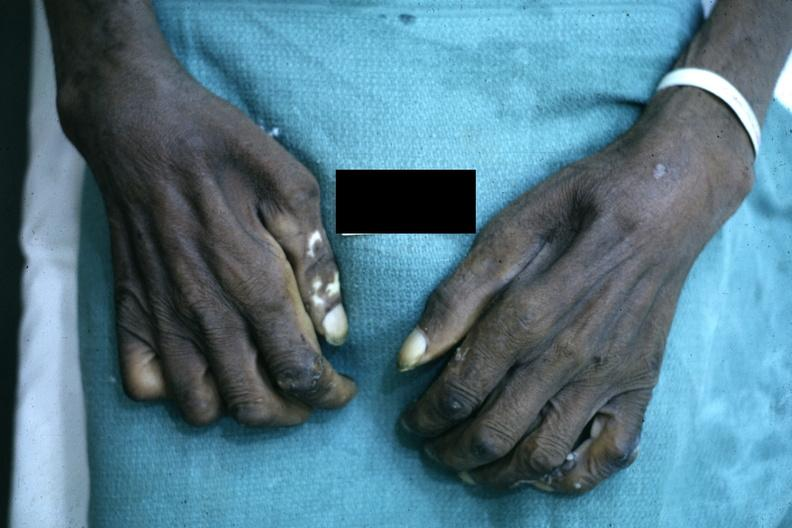s outside adrenal capsule section present?
Answer the question using a single word or phrase. No 